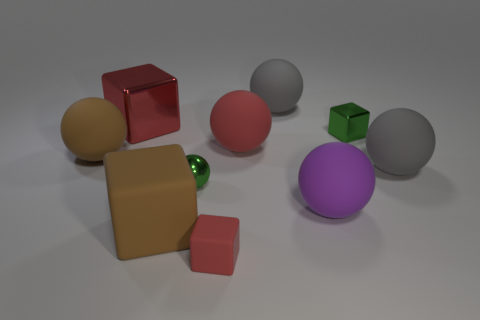Is the number of purple objects that are on the right side of the purple ball greater than the number of purple rubber things?
Provide a succinct answer. No. Are there any other things that are the same material as the red sphere?
Provide a short and direct response. Yes. There is a thing that is behind the large red metallic thing; is it the same color as the tiny rubber cube on the left side of the green cube?
Your answer should be compact. No. What material is the gray ball that is in front of the large gray ball that is behind the block behind the tiny green metal block?
Offer a terse response. Rubber. Is the number of small matte objects greater than the number of big cyan metallic spheres?
Your answer should be very brief. Yes. Are there any other things of the same color as the tiny shiny sphere?
Your response must be concise. Yes. What size is the red thing that is made of the same material as the green sphere?
Offer a very short reply. Large. What is the large purple sphere made of?
Keep it short and to the point. Rubber. What number of gray objects are the same size as the purple object?
Give a very brief answer. 2. There is a small thing that is the same color as the big shiny object; what is its shape?
Offer a terse response. Cube. 